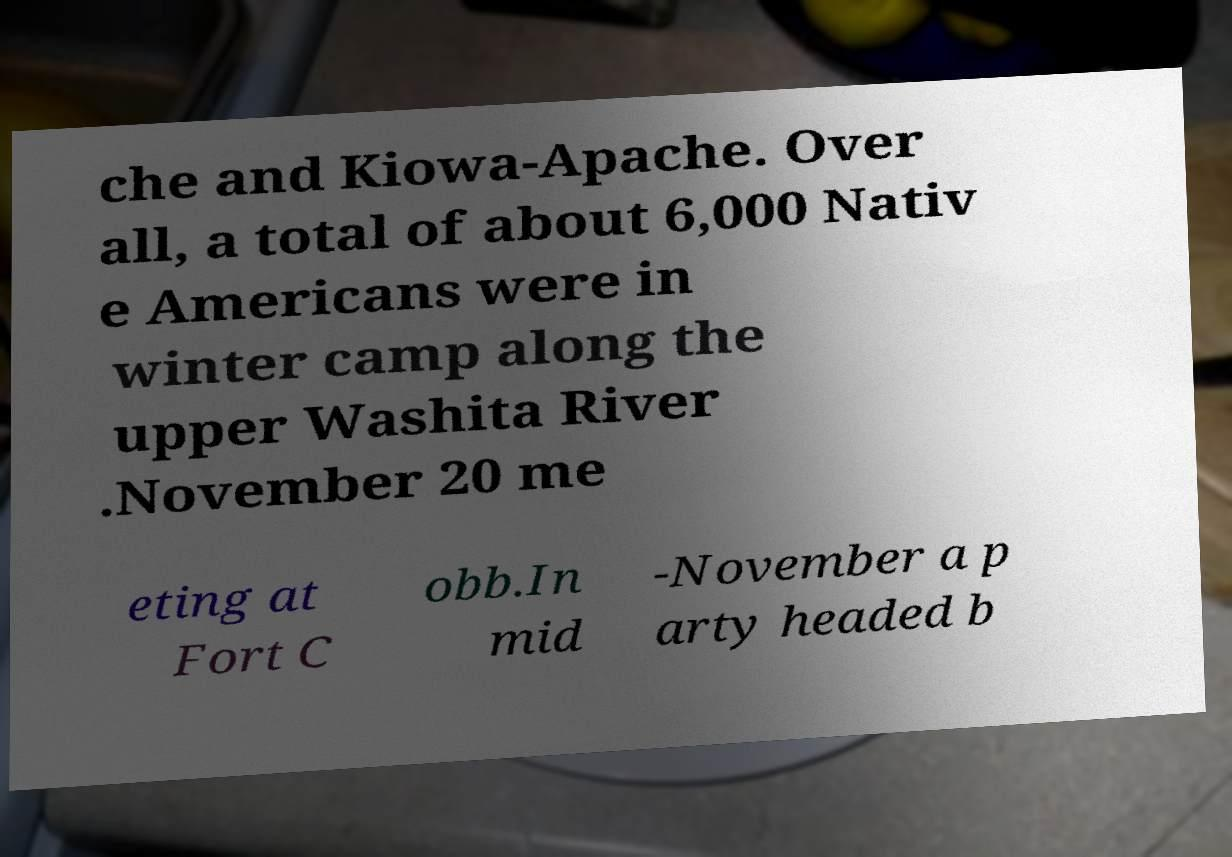For documentation purposes, I need the text within this image transcribed. Could you provide that? che and Kiowa-Apache. Over all, a total of about 6,000 Nativ e Americans were in winter camp along the upper Washita River .November 20 me eting at Fort C obb.In mid -November a p arty headed b 